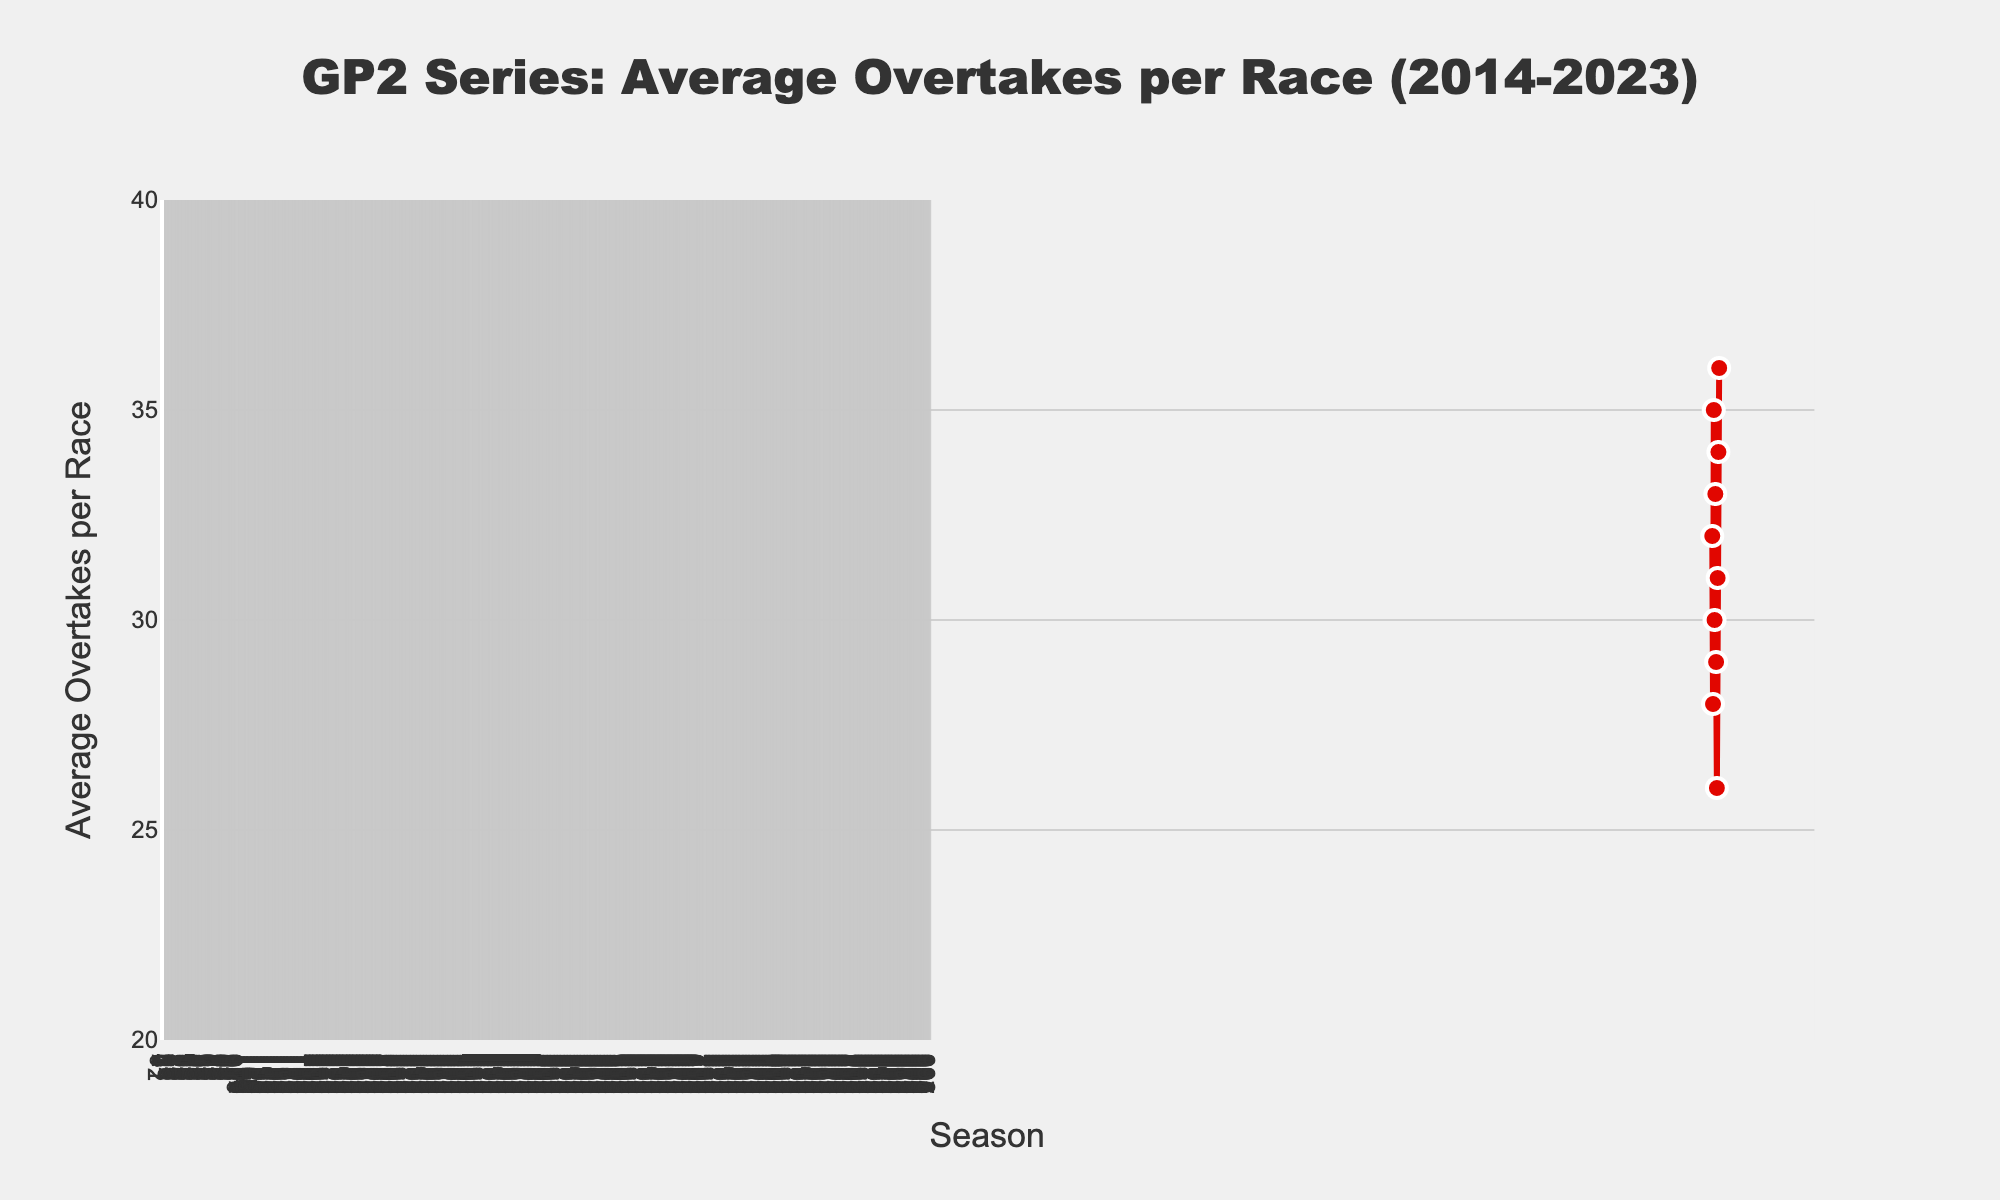What was the average number of overtakes per race in the 2020 season? Refer to the data corresponding to the 2020 season, where the average overtakes per race are marked as 26.
Answer: 26 Which season had the highest average number of overtakes per race? Examine the data across all seasons and identify that the 2023 season had the highest average number of overtakes per race, which is 36.
Answer: 2023 What is the difference in the average number of overtakes between the 2016 and 2020 seasons? Subtract the average number of overtakes in 2020 (26) from that of 2016 (35). The difference is 35 - 26.
Answer: 9 Did the average number of overtakes per race increase or decrease from 2019 to 2020? Compare the average overtakes in 2019 (29) to those in 2020 (26). The value decreased.
Answer: Decrease How many times did the average number of overtakes exceed 30 overtakes per race in the given timeframe? Count the number of seasons where the average overtakes were above 30: 2014, 2016, 2018, 2021, 2022, and 2023. There are 6 such seasons.
Answer: 6 What is the average number of overtakes per race over the first five seasons (2014-2018)? Sum the overtakes for 2014 (32), 2015 (28), 2016 (35), 2017 (30), and 2018 (33) and then divide by 5. Average is (32+28+35+30+33)/5 = 31.6.
Answer: 31.6 Which season showed a greater increase in average overtakes compared to the previous season: 2015 to 2016 or 2021 to 2022? Calculate the increase from 2015 to 2016 (35-28 = 7) and compare it with 2021 to 2022 (34-31 = 3). 2015 to 2016 had a greater increase.
Answer: 2015 to 2016 How many times did the average number of overtakes per race decrease compared to the previous season? Identify the seasons where there was a decrease from the previous year: 2015 (from 32 to 28), 2017 (from 35 to 30), 2019 (from 33 to 29), and 2020 (from 29 to 26). This occurred 4 times.
Answer: 4 What is the range of average overtakes per race during the last ten seasons? Find the maximum (36 in 2023) and minimum (26 in 2020) values over the period. The range is 36 - 26.
Answer: 10 